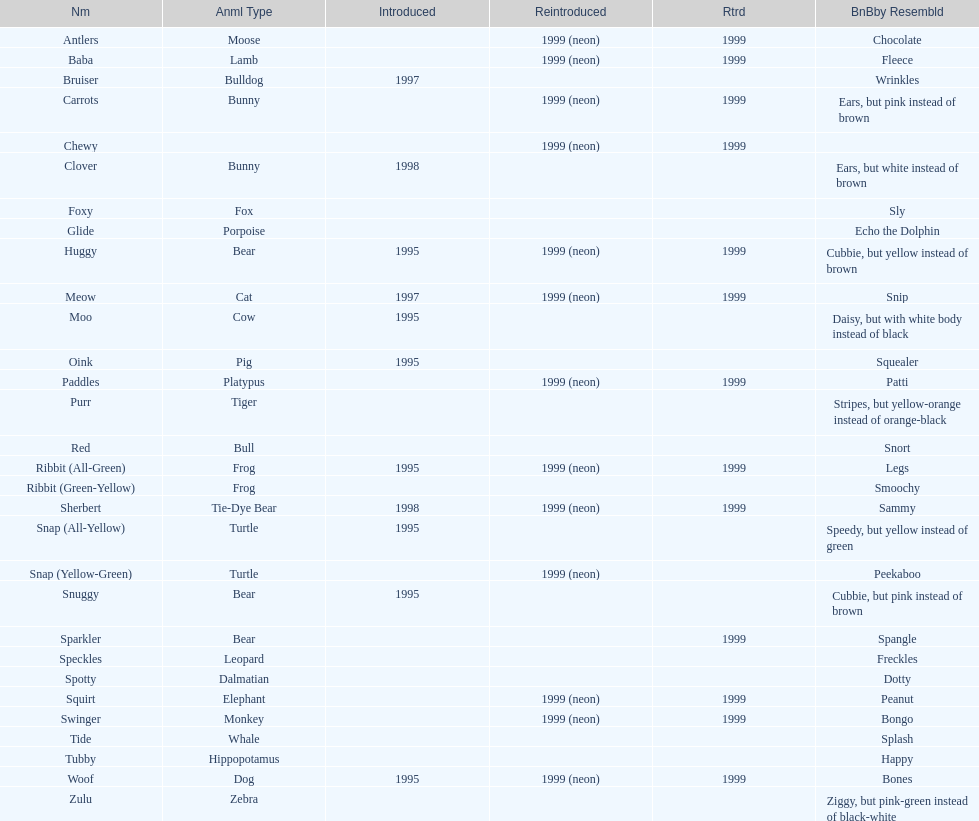How long was woof the dog sold before it was retired? 4 years. 